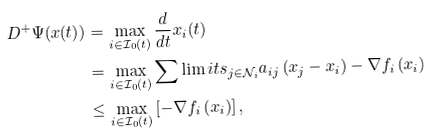Convert formula to latex. <formula><loc_0><loc_0><loc_500><loc_500>D ^ { + } \Psi ( x ( t ) ) & = \max _ { i \in \mathcal { I } _ { 0 } ( t ) } \frac { d } { d t } x _ { i } ( t ) \\ & = \max _ { i \in \mathcal { I } _ { 0 } ( t ) } \sum \lim i t s _ { j \in \mathcal { N } _ { i } } a _ { i j } \left ( x _ { j } - x _ { i } \right ) - \nabla f _ { i } \left ( x _ { i } \right ) \\ & \leq \max _ { i \in \mathcal { I } _ { 0 } ( t ) } \left [ - \nabla f _ { i } \left ( x _ { i } \right ) \right ] ,</formula> 